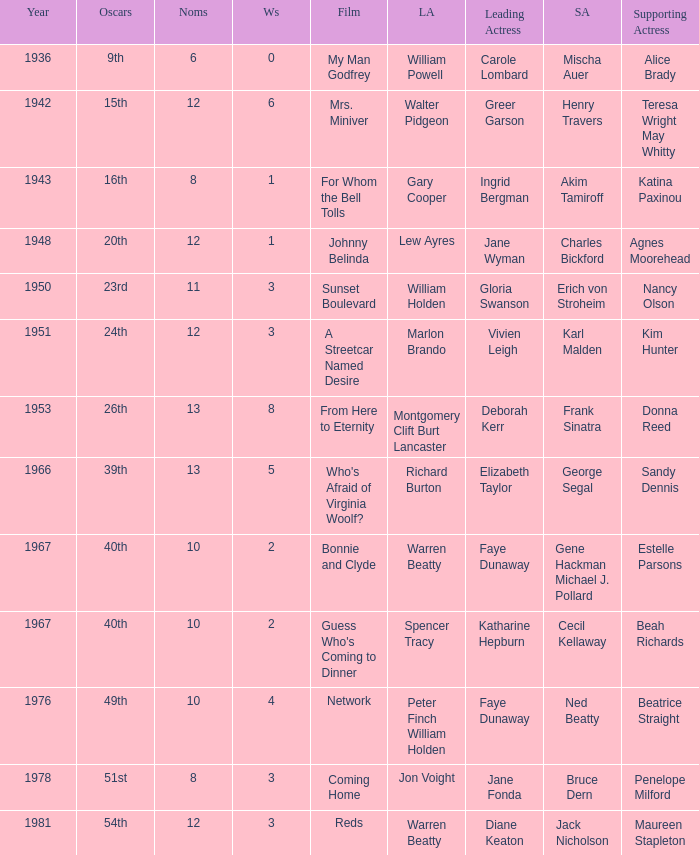Who was the supporting actress in 1943? Katina Paxinou. 